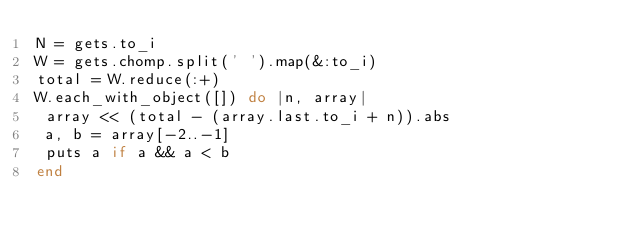<code> <loc_0><loc_0><loc_500><loc_500><_Ruby_>N = gets.to_i
W = gets.chomp.split(' ').map(&:to_i)
total = W.reduce(:+)
W.each_with_object([]) do |n, array|
 array << (total - (array.last.to_i + n)).abs
 a, b = array[-2..-1]
 puts a if a && a < b
end</code> 